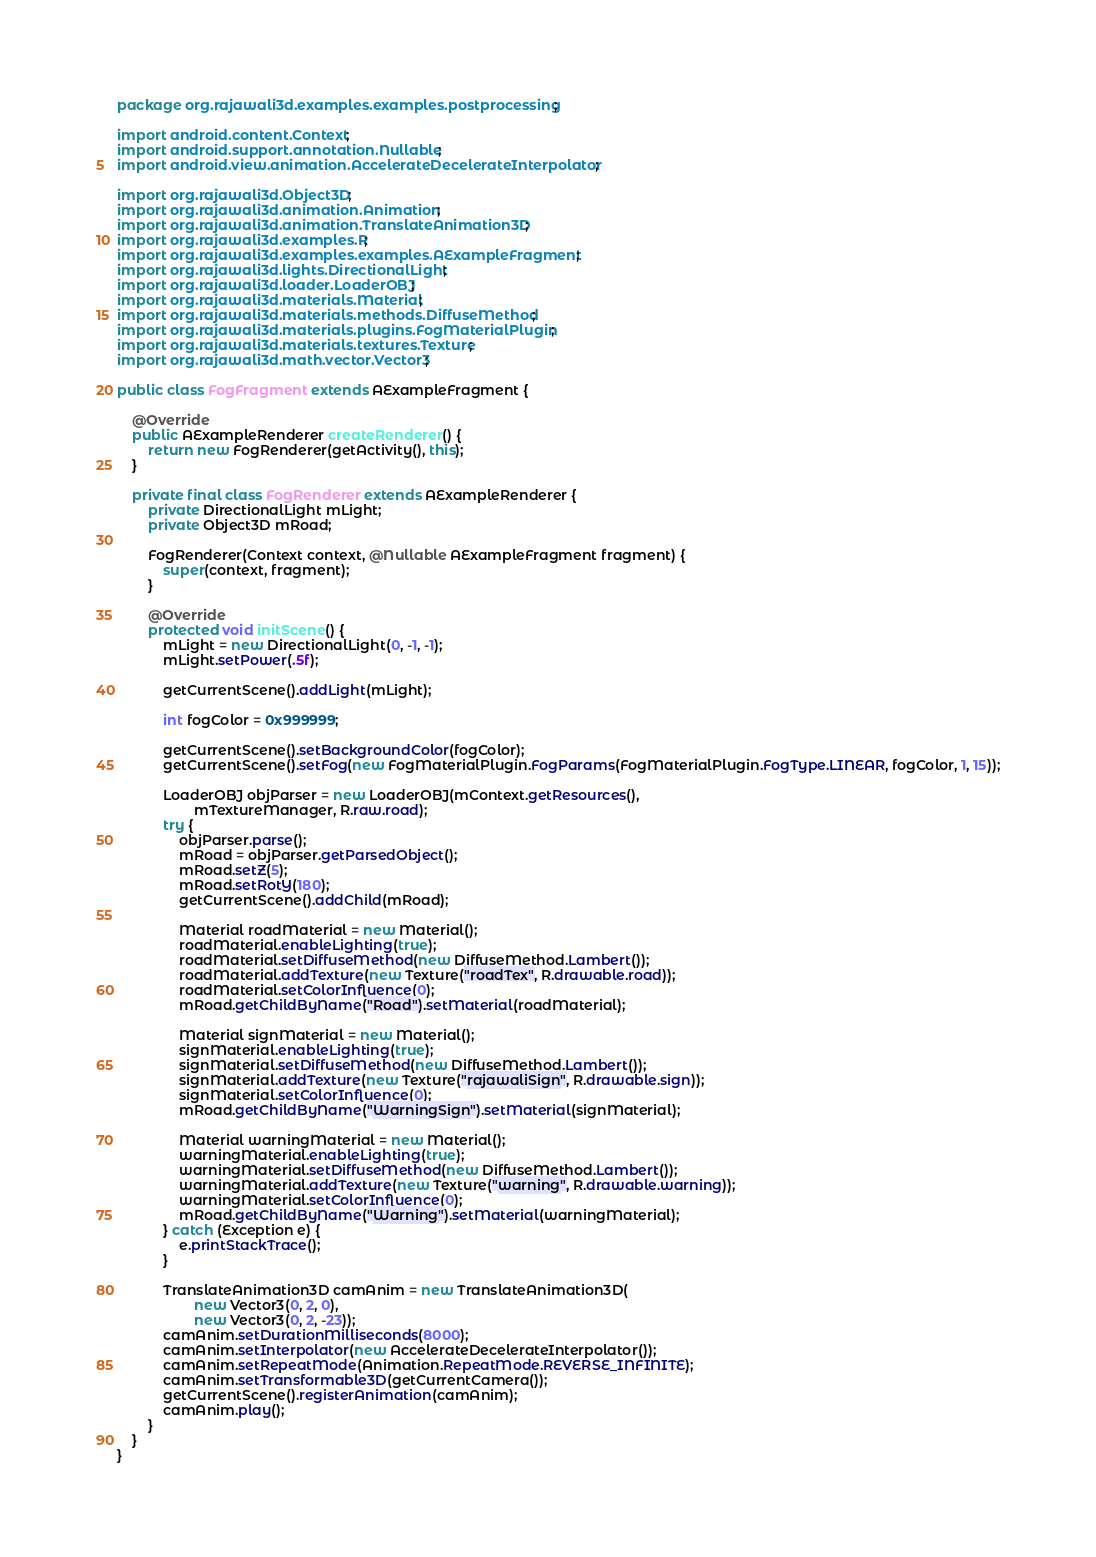Convert code to text. <code><loc_0><loc_0><loc_500><loc_500><_Java_>package org.rajawali3d.examples.examples.postprocessing;

import android.content.Context;
import android.support.annotation.Nullable;
import android.view.animation.AccelerateDecelerateInterpolator;

import org.rajawali3d.Object3D;
import org.rajawali3d.animation.Animation;
import org.rajawali3d.animation.TranslateAnimation3D;
import org.rajawali3d.examples.R;
import org.rajawali3d.examples.examples.AExampleFragment;
import org.rajawali3d.lights.DirectionalLight;
import org.rajawali3d.loader.LoaderOBJ;
import org.rajawali3d.materials.Material;
import org.rajawali3d.materials.methods.DiffuseMethod;
import org.rajawali3d.materials.plugins.FogMaterialPlugin;
import org.rajawali3d.materials.textures.Texture;
import org.rajawali3d.math.vector.Vector3;

public class FogFragment extends AExampleFragment {

    @Override
    public AExampleRenderer createRenderer() {
        return new FogRenderer(getActivity(), this);
    }

    private final class FogRenderer extends AExampleRenderer {
        private DirectionalLight mLight;
        private Object3D mRoad;

        FogRenderer(Context context, @Nullable AExampleFragment fragment) {
            super(context, fragment);
        }

        @Override
        protected void initScene() {
            mLight = new DirectionalLight(0, -1, -1);
            mLight.setPower(.5f);

            getCurrentScene().addLight(mLight);

            int fogColor = 0x999999;

            getCurrentScene().setBackgroundColor(fogColor);
            getCurrentScene().setFog(new FogMaterialPlugin.FogParams(FogMaterialPlugin.FogType.LINEAR, fogColor, 1, 15));

            LoaderOBJ objParser = new LoaderOBJ(mContext.getResources(),
                    mTextureManager, R.raw.road);
            try {
                objParser.parse();
                mRoad = objParser.getParsedObject();
                mRoad.setZ(5);
                mRoad.setRotY(180);
                getCurrentScene().addChild(mRoad);

                Material roadMaterial = new Material();
                roadMaterial.enableLighting(true);
                roadMaterial.setDiffuseMethod(new DiffuseMethod.Lambert());
                roadMaterial.addTexture(new Texture("roadTex", R.drawable.road));
                roadMaterial.setColorInfluence(0);
                mRoad.getChildByName("Road").setMaterial(roadMaterial);

                Material signMaterial = new Material();
                signMaterial.enableLighting(true);
                signMaterial.setDiffuseMethod(new DiffuseMethod.Lambert());
                signMaterial.addTexture(new Texture("rajawaliSign", R.drawable.sign));
                signMaterial.setColorInfluence(0);
                mRoad.getChildByName("WarningSign").setMaterial(signMaterial);

                Material warningMaterial = new Material();
                warningMaterial.enableLighting(true);
                warningMaterial.setDiffuseMethod(new DiffuseMethod.Lambert());
                warningMaterial.addTexture(new Texture("warning", R.drawable.warning));
                warningMaterial.setColorInfluence(0);
                mRoad.getChildByName("Warning").setMaterial(warningMaterial);
            } catch (Exception e) {
                e.printStackTrace();
            }

            TranslateAnimation3D camAnim = new TranslateAnimation3D(
                    new Vector3(0, 2, 0),
                    new Vector3(0, 2, -23));
            camAnim.setDurationMilliseconds(8000);
            camAnim.setInterpolator(new AccelerateDecelerateInterpolator());
            camAnim.setRepeatMode(Animation.RepeatMode.REVERSE_INFINITE);
            camAnim.setTransformable3D(getCurrentCamera());
            getCurrentScene().registerAnimation(camAnim);
            camAnim.play();
        }
    }
}
</code> 